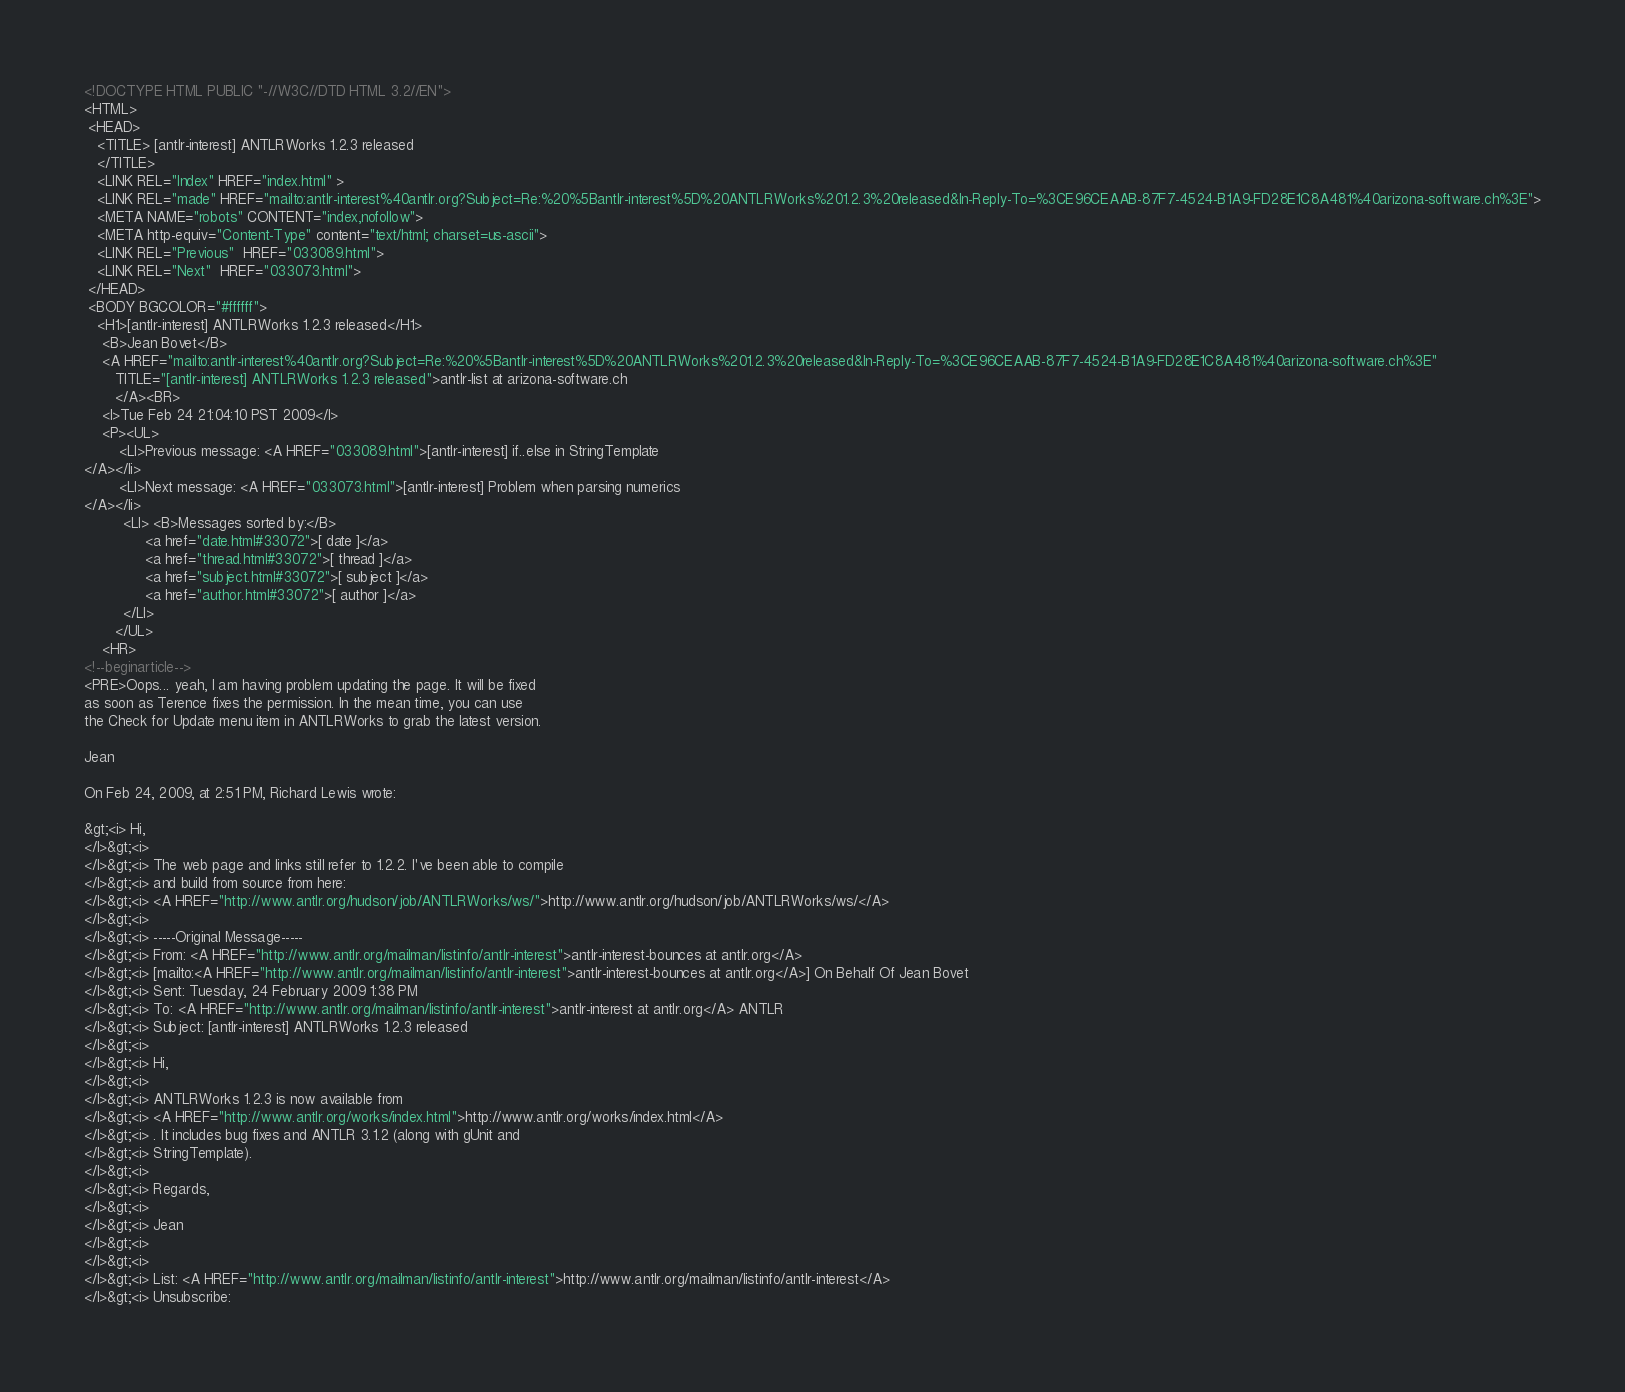<code> <loc_0><loc_0><loc_500><loc_500><_HTML_><!DOCTYPE HTML PUBLIC "-//W3C//DTD HTML 3.2//EN">
<HTML>
 <HEAD>
   <TITLE> [antlr-interest] ANTLRWorks 1.2.3 released
   </TITLE>
   <LINK REL="Index" HREF="index.html" >
   <LINK REL="made" HREF="mailto:antlr-interest%40antlr.org?Subject=Re:%20%5Bantlr-interest%5D%20ANTLRWorks%201.2.3%20released&In-Reply-To=%3CE96CEAAB-87F7-4524-B1A9-FD28E1C8A481%40arizona-software.ch%3E">
   <META NAME="robots" CONTENT="index,nofollow">
   <META http-equiv="Content-Type" content="text/html; charset=us-ascii">
   <LINK REL="Previous"  HREF="033089.html">
   <LINK REL="Next"  HREF="033073.html">
 </HEAD>
 <BODY BGCOLOR="#ffffff">
   <H1>[antlr-interest] ANTLRWorks 1.2.3 released</H1>
    <B>Jean Bovet</B> 
    <A HREF="mailto:antlr-interest%40antlr.org?Subject=Re:%20%5Bantlr-interest%5D%20ANTLRWorks%201.2.3%20released&In-Reply-To=%3CE96CEAAB-87F7-4524-B1A9-FD28E1C8A481%40arizona-software.ch%3E"
       TITLE="[antlr-interest] ANTLRWorks 1.2.3 released">antlr-list at arizona-software.ch
       </A><BR>
    <I>Tue Feb 24 21:04:10 PST 2009</I>
    <P><UL>
        <LI>Previous message: <A HREF="033089.html">[antlr-interest] if..else in StringTemplate
</A></li>
        <LI>Next message: <A HREF="033073.html">[antlr-interest] Problem when parsing numerics
</A></li>
         <LI> <B>Messages sorted by:</B> 
              <a href="date.html#33072">[ date ]</a>
              <a href="thread.html#33072">[ thread ]</a>
              <a href="subject.html#33072">[ subject ]</a>
              <a href="author.html#33072">[ author ]</a>
         </LI>
       </UL>
    <HR>  
<!--beginarticle-->
<PRE>Oops... yeah, I am having problem updating the page. It will be fixed  
as soon as Terence fixes the permission. In the mean time, you can use  
the Check for Update menu item in ANTLRWorks to grab the latest version.

Jean

On Feb 24, 2009, at 2:51 PM, Richard Lewis wrote:

&gt;<i> Hi,
</I>&gt;<i>
</I>&gt;<i> The web page and links still refer to 1.2.2. I've been able to compile
</I>&gt;<i> and build from source from here:
</I>&gt;<i> <A HREF="http://www.antlr.org/hudson/job/ANTLRWorks/ws/">http://www.antlr.org/hudson/job/ANTLRWorks/ws/</A>
</I>&gt;<i>
</I>&gt;<i> -----Original Message-----
</I>&gt;<i> From: <A HREF="http://www.antlr.org/mailman/listinfo/antlr-interest">antlr-interest-bounces at antlr.org</A>
</I>&gt;<i> [mailto:<A HREF="http://www.antlr.org/mailman/listinfo/antlr-interest">antlr-interest-bounces at antlr.org</A>] On Behalf Of Jean Bovet
</I>&gt;<i> Sent: Tuesday, 24 February 2009 1:38 PM
</I>&gt;<i> To: <A HREF="http://www.antlr.org/mailman/listinfo/antlr-interest">antlr-interest at antlr.org</A> ANTLR
</I>&gt;<i> Subject: [antlr-interest] ANTLRWorks 1.2.3 released
</I>&gt;<i>
</I>&gt;<i> Hi,
</I>&gt;<i>
</I>&gt;<i> ANTLRWorks 1.2.3 is now available from
</I>&gt;<i> <A HREF="http://www.antlr.org/works/index.html">http://www.antlr.org/works/index.html</A>
</I>&gt;<i> . It includes bug fixes and ANTLR 3.1.2 (along with gUnit and
</I>&gt;<i> StringTemplate).
</I>&gt;<i>
</I>&gt;<i> Regards,
</I>&gt;<i>
</I>&gt;<i> Jean
</I>&gt;<i>
</I>&gt;<i>
</I>&gt;<i> List: <A HREF="http://www.antlr.org/mailman/listinfo/antlr-interest">http://www.antlr.org/mailman/listinfo/antlr-interest</A>
</I>&gt;<i> Unsubscribe:</code> 